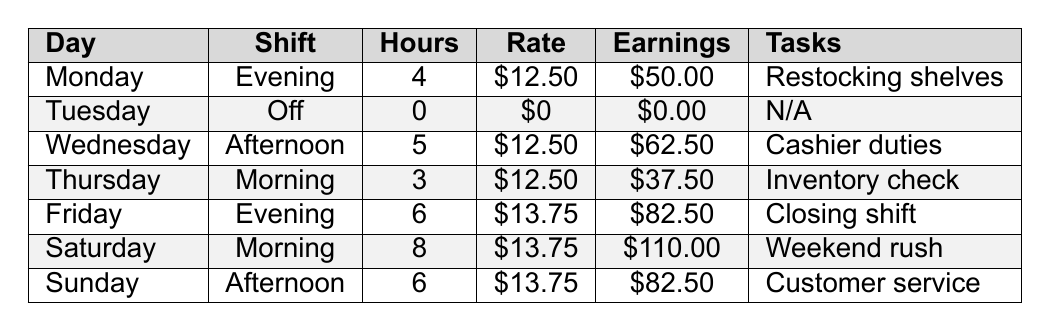What are the total hours worked in the week? To find the total hours worked, sum the hours from each day: 4 + 0 + 5 + 3 + 6 + 8 + 6 = 32 hours.
Answer: 32 hours How much did you earn on Saturday? The daily earnings listed for Saturday are $110.00.
Answer: $110.00 Which day had the highest hourly rate? Comparing the hourly rates, Saturday, Friday, and Sunday all have the highest rate of $13.75, but Saturday had the most hours.
Answer: Saturday, Friday, and Sunday ($13.75) Did you work on Tuesday? The table shows that Tuesday is an "Off" day with 0 hours worked, so you did not work on that day.
Answer: No What are the total earnings for the week? Summing the daily earnings gives: 50.00 + 0.00 + 62.50 + 37.50 + 82.50 + 110.00 + 82.50 = $322.50.
Answer: $322.50 Which day did you work the least hours? The least hours worked were on Thursday with 3 hours.
Answer: Thursday What was your average hourly rate for the week? To find the average, calculate total pay divided by total hours: ($50 + $62.50 + $37.50 + $82.50 + $110 + $82.50) / 32 = $322.50 / 32 = $10.09.
Answer: $10.09 On which day did you work more than 5 hours? The days with more than 5 hours are Saturday (8) and Friday (6).
Answer: Saturday and Friday If you didn't work on Tuesday, which day had the most tasks? Saturday had the most tasks listed as "Weekend rush", paired with the highest hours, making it noteworthy.
Answer: Saturday What is the total earnings difference between Saturday and Monday? Subtracting Monday's earnings ($50.00) from Saturday's earnings ($110.00) gives $110.00 - $50.00 = $60.00.
Answer: $60.00 